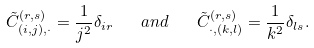<formula> <loc_0><loc_0><loc_500><loc_500>\tilde { C } _ { ( i , j ) , \cdot } ^ { ( r , s ) } = \frac { 1 } { j ^ { 2 } } \delta _ { i r } \quad a n d \quad \tilde { C } _ { \cdot , ( k , l ) } ^ { ( r , s ) } = \frac { 1 } { k ^ { 2 } } \delta _ { l s } .</formula> 